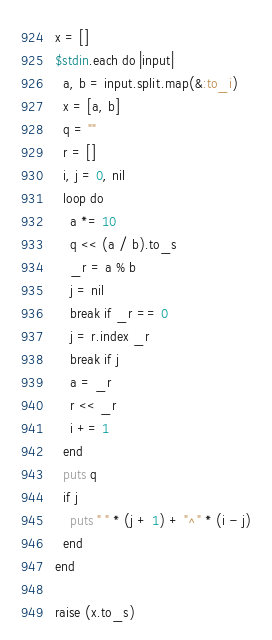<code> <loc_0><loc_0><loc_500><loc_500><_Ruby_>x = []
$stdin.each do |input|
  a, b = input.split.map(&:to_i)
  x = [a, b]
  q = ""
  r = []
  i, j = 0, nil
  loop do
    a *= 10
    q << (a / b).to_s
    _r = a % b
    j = nil
    break if _r == 0
    j = r.index _r
    break if j
    a = _r
    r << _r
    i += 1
  end
  puts q
  if j
    puts " " * (j + 1) + "^" * (i - j)
  end
end

raise (x.to_s)</code> 